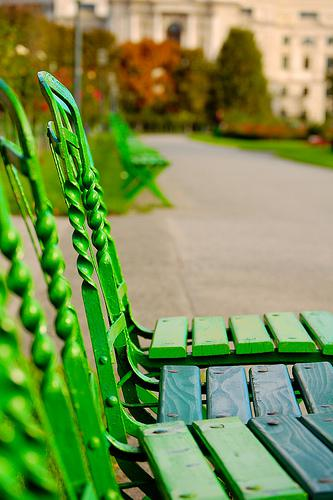Question: what color are the chairs?
Choices:
A. Grey.
B. Brown.
C. Green.
D. Beige.
Answer with the letter. Answer: C Question: why are the chairs there?
Choices:
A. To stand on.
B. To rest clothes on.
C. To sleep in.
D. For people to sit.
Answer with the letter. Answer: D Question: who is sitting in the chairs?
Choices:
A. People.
B. Dogs.
C. Cats.
D. No one.
Answer with the letter. Answer: D Question: how are the chairs positioned?
Choices:
A. In a circle.
B. Next to each other.
C. In rows.
D. Along the walls.
Answer with the letter. Answer: B Question: what color is the building?
Choices:
A. Blue.
B. Pink.
C. White.
D. Grey.
Answer with the letter. Answer: C 